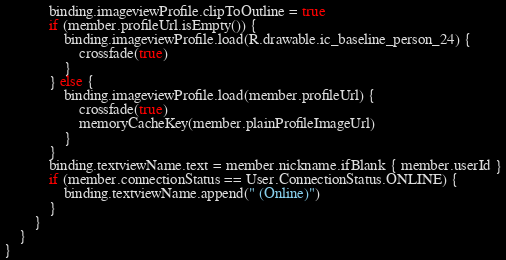<code> <loc_0><loc_0><loc_500><loc_500><_Kotlin_>            binding.imageviewProfile.clipToOutline = true
            if (member.profileUrl.isEmpty()) {
                binding.imageviewProfile.load(R.drawable.ic_baseline_person_24) {
                    crossfade(true)
                }
            } else {
                binding.imageviewProfile.load(member.profileUrl) {
                    crossfade(true)
                    memoryCacheKey(member.plainProfileImageUrl)
                }
            }
            binding.textviewName.text = member.nickname.ifBlank { member.userId }
            if (member.connectionStatus == User.ConnectionStatus.ONLINE) {
                binding.textviewName.append(" (Online)")
            }
        }
    }
}</code> 